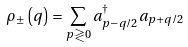Convert formula to latex. <formula><loc_0><loc_0><loc_500><loc_500>\rho _ { \pm } \left ( q \right ) = \sum _ { p \gtrless 0 } a _ { p - q / 2 } ^ { \dagger } a _ { p + q / 2 }</formula> 